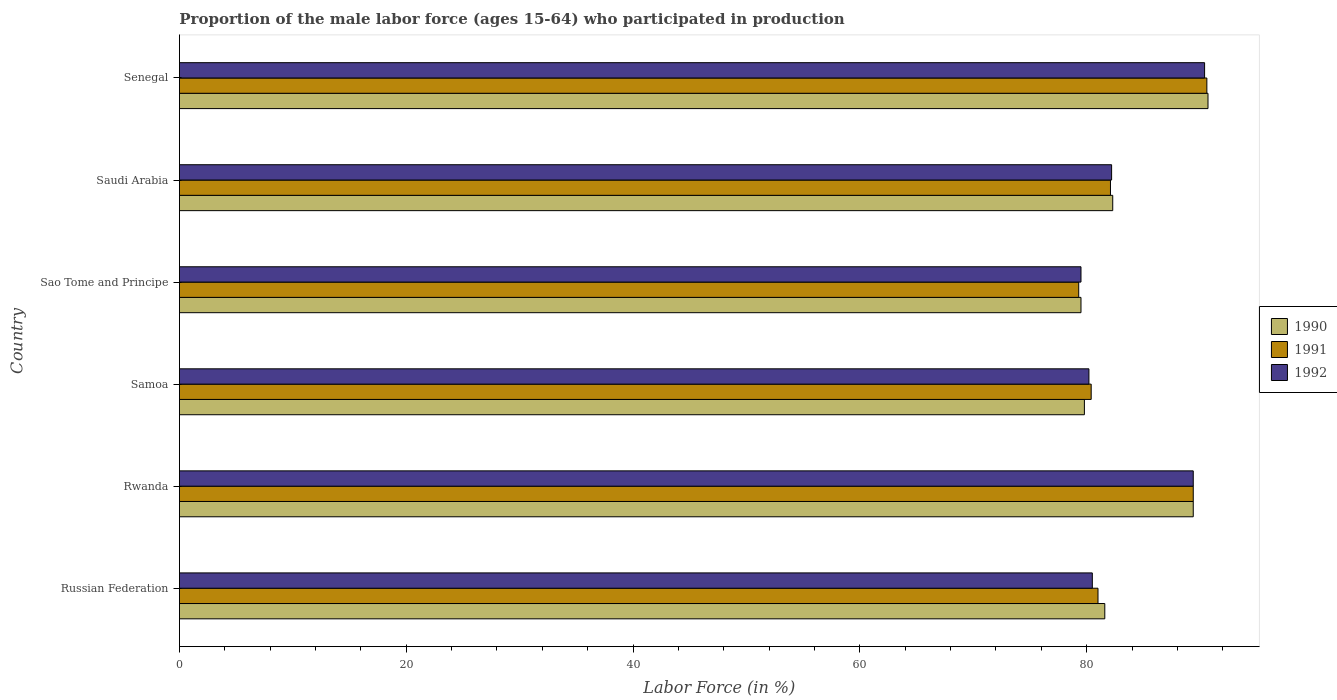How many groups of bars are there?
Offer a very short reply. 6. Are the number of bars on each tick of the Y-axis equal?
Provide a succinct answer. Yes. How many bars are there on the 6th tick from the top?
Your response must be concise. 3. What is the label of the 5th group of bars from the top?
Keep it short and to the point. Rwanda. What is the proportion of the male labor force who participated in production in 1990 in Saudi Arabia?
Provide a succinct answer. 82.3. Across all countries, what is the maximum proportion of the male labor force who participated in production in 1990?
Keep it short and to the point. 90.7. Across all countries, what is the minimum proportion of the male labor force who participated in production in 1992?
Give a very brief answer. 79.5. In which country was the proportion of the male labor force who participated in production in 1990 maximum?
Give a very brief answer. Senegal. In which country was the proportion of the male labor force who participated in production in 1991 minimum?
Offer a terse response. Sao Tome and Principe. What is the total proportion of the male labor force who participated in production in 1991 in the graph?
Ensure brevity in your answer.  502.8. What is the difference between the proportion of the male labor force who participated in production in 1992 in Samoa and that in Saudi Arabia?
Make the answer very short. -2. What is the difference between the proportion of the male labor force who participated in production in 1992 in Rwanda and the proportion of the male labor force who participated in production in 1990 in Sao Tome and Principe?
Give a very brief answer. 9.9. What is the average proportion of the male labor force who participated in production in 1992 per country?
Offer a very short reply. 83.7. What is the difference between the proportion of the male labor force who participated in production in 1992 and proportion of the male labor force who participated in production in 1991 in Saudi Arabia?
Provide a succinct answer. 0.1. What is the ratio of the proportion of the male labor force who participated in production in 1992 in Russian Federation to that in Sao Tome and Principe?
Make the answer very short. 1.01. Is the proportion of the male labor force who participated in production in 1990 in Russian Federation less than that in Senegal?
Your answer should be very brief. Yes. What is the difference between the highest and the lowest proportion of the male labor force who participated in production in 1991?
Provide a succinct answer. 11.3. In how many countries, is the proportion of the male labor force who participated in production in 1991 greater than the average proportion of the male labor force who participated in production in 1991 taken over all countries?
Your answer should be compact. 2. What does the 1st bar from the top in Saudi Arabia represents?
Your answer should be compact. 1992. Is it the case that in every country, the sum of the proportion of the male labor force who participated in production in 1991 and proportion of the male labor force who participated in production in 1992 is greater than the proportion of the male labor force who participated in production in 1990?
Your answer should be compact. Yes. How many countries are there in the graph?
Your response must be concise. 6. What is the difference between two consecutive major ticks on the X-axis?
Your answer should be very brief. 20. Does the graph contain grids?
Make the answer very short. No. Where does the legend appear in the graph?
Give a very brief answer. Center right. What is the title of the graph?
Keep it short and to the point. Proportion of the male labor force (ages 15-64) who participated in production. What is the label or title of the Y-axis?
Give a very brief answer. Country. What is the Labor Force (in %) of 1990 in Russian Federation?
Offer a very short reply. 81.6. What is the Labor Force (in %) in 1992 in Russian Federation?
Offer a very short reply. 80.5. What is the Labor Force (in %) of 1990 in Rwanda?
Your response must be concise. 89.4. What is the Labor Force (in %) of 1991 in Rwanda?
Provide a short and direct response. 89.4. What is the Labor Force (in %) in 1992 in Rwanda?
Your response must be concise. 89.4. What is the Labor Force (in %) in 1990 in Samoa?
Give a very brief answer. 79.8. What is the Labor Force (in %) in 1991 in Samoa?
Your response must be concise. 80.4. What is the Labor Force (in %) of 1992 in Samoa?
Ensure brevity in your answer.  80.2. What is the Labor Force (in %) in 1990 in Sao Tome and Principe?
Provide a short and direct response. 79.5. What is the Labor Force (in %) in 1991 in Sao Tome and Principe?
Keep it short and to the point. 79.3. What is the Labor Force (in %) in 1992 in Sao Tome and Principe?
Your answer should be very brief. 79.5. What is the Labor Force (in %) in 1990 in Saudi Arabia?
Give a very brief answer. 82.3. What is the Labor Force (in %) of 1991 in Saudi Arabia?
Your response must be concise. 82.1. What is the Labor Force (in %) in 1992 in Saudi Arabia?
Provide a succinct answer. 82.2. What is the Labor Force (in %) in 1990 in Senegal?
Ensure brevity in your answer.  90.7. What is the Labor Force (in %) of 1991 in Senegal?
Provide a succinct answer. 90.6. What is the Labor Force (in %) of 1992 in Senegal?
Provide a short and direct response. 90.4. Across all countries, what is the maximum Labor Force (in %) in 1990?
Give a very brief answer. 90.7. Across all countries, what is the maximum Labor Force (in %) of 1991?
Keep it short and to the point. 90.6. Across all countries, what is the maximum Labor Force (in %) of 1992?
Make the answer very short. 90.4. Across all countries, what is the minimum Labor Force (in %) of 1990?
Provide a succinct answer. 79.5. Across all countries, what is the minimum Labor Force (in %) of 1991?
Your answer should be compact. 79.3. Across all countries, what is the minimum Labor Force (in %) in 1992?
Provide a short and direct response. 79.5. What is the total Labor Force (in %) in 1990 in the graph?
Provide a succinct answer. 503.3. What is the total Labor Force (in %) in 1991 in the graph?
Give a very brief answer. 502.8. What is the total Labor Force (in %) in 1992 in the graph?
Make the answer very short. 502.2. What is the difference between the Labor Force (in %) in 1992 in Russian Federation and that in Samoa?
Give a very brief answer. 0.3. What is the difference between the Labor Force (in %) of 1990 in Russian Federation and that in Sao Tome and Principe?
Offer a very short reply. 2.1. What is the difference between the Labor Force (in %) in 1991 in Russian Federation and that in Sao Tome and Principe?
Your answer should be very brief. 1.7. What is the difference between the Labor Force (in %) of 1992 in Russian Federation and that in Saudi Arabia?
Provide a succinct answer. -1.7. What is the difference between the Labor Force (in %) in 1990 in Rwanda and that in Samoa?
Ensure brevity in your answer.  9.6. What is the difference between the Labor Force (in %) of 1991 in Rwanda and that in Samoa?
Provide a short and direct response. 9. What is the difference between the Labor Force (in %) of 1992 in Rwanda and that in Samoa?
Provide a succinct answer. 9.2. What is the difference between the Labor Force (in %) of 1990 in Rwanda and that in Sao Tome and Principe?
Make the answer very short. 9.9. What is the difference between the Labor Force (in %) of 1992 in Rwanda and that in Sao Tome and Principe?
Keep it short and to the point. 9.9. What is the difference between the Labor Force (in %) in 1990 in Rwanda and that in Saudi Arabia?
Ensure brevity in your answer.  7.1. What is the difference between the Labor Force (in %) of 1992 in Rwanda and that in Saudi Arabia?
Keep it short and to the point. 7.2. What is the difference between the Labor Force (in %) in 1990 in Rwanda and that in Senegal?
Keep it short and to the point. -1.3. What is the difference between the Labor Force (in %) of 1992 in Rwanda and that in Senegal?
Ensure brevity in your answer.  -1. What is the difference between the Labor Force (in %) of 1990 in Samoa and that in Saudi Arabia?
Offer a very short reply. -2.5. What is the difference between the Labor Force (in %) of 1990 in Samoa and that in Senegal?
Give a very brief answer. -10.9. What is the difference between the Labor Force (in %) in 1991 in Samoa and that in Senegal?
Your response must be concise. -10.2. What is the difference between the Labor Force (in %) in 1990 in Sao Tome and Principe and that in Saudi Arabia?
Give a very brief answer. -2.8. What is the difference between the Labor Force (in %) in 1992 in Sao Tome and Principe and that in Saudi Arabia?
Your answer should be compact. -2.7. What is the difference between the Labor Force (in %) in 1992 in Sao Tome and Principe and that in Senegal?
Give a very brief answer. -10.9. What is the difference between the Labor Force (in %) in 1990 in Saudi Arabia and that in Senegal?
Your answer should be very brief. -8.4. What is the difference between the Labor Force (in %) of 1991 in Saudi Arabia and that in Senegal?
Ensure brevity in your answer.  -8.5. What is the difference between the Labor Force (in %) of 1992 in Saudi Arabia and that in Senegal?
Provide a short and direct response. -8.2. What is the difference between the Labor Force (in %) of 1990 in Russian Federation and the Labor Force (in %) of 1991 in Rwanda?
Your answer should be very brief. -7.8. What is the difference between the Labor Force (in %) in 1990 in Russian Federation and the Labor Force (in %) in 1991 in Samoa?
Ensure brevity in your answer.  1.2. What is the difference between the Labor Force (in %) of 1990 in Russian Federation and the Labor Force (in %) of 1992 in Samoa?
Offer a terse response. 1.4. What is the difference between the Labor Force (in %) in 1991 in Russian Federation and the Labor Force (in %) in 1992 in Samoa?
Provide a short and direct response. 0.8. What is the difference between the Labor Force (in %) of 1990 in Russian Federation and the Labor Force (in %) of 1992 in Sao Tome and Principe?
Provide a succinct answer. 2.1. What is the difference between the Labor Force (in %) in 1991 in Russian Federation and the Labor Force (in %) in 1992 in Sao Tome and Principe?
Your response must be concise. 1.5. What is the difference between the Labor Force (in %) in 1990 in Russian Federation and the Labor Force (in %) in 1992 in Saudi Arabia?
Keep it short and to the point. -0.6. What is the difference between the Labor Force (in %) in 1991 in Russian Federation and the Labor Force (in %) in 1992 in Saudi Arabia?
Give a very brief answer. -1.2. What is the difference between the Labor Force (in %) of 1990 in Russian Federation and the Labor Force (in %) of 1991 in Senegal?
Offer a terse response. -9. What is the difference between the Labor Force (in %) in 1990 in Russian Federation and the Labor Force (in %) in 1992 in Senegal?
Provide a succinct answer. -8.8. What is the difference between the Labor Force (in %) of 1991 in Russian Federation and the Labor Force (in %) of 1992 in Senegal?
Give a very brief answer. -9.4. What is the difference between the Labor Force (in %) of 1990 in Rwanda and the Labor Force (in %) of 1991 in Samoa?
Your answer should be very brief. 9. What is the difference between the Labor Force (in %) in 1991 in Rwanda and the Labor Force (in %) in 1992 in Samoa?
Provide a succinct answer. 9.2. What is the difference between the Labor Force (in %) of 1990 in Rwanda and the Labor Force (in %) of 1991 in Sao Tome and Principe?
Provide a succinct answer. 10.1. What is the difference between the Labor Force (in %) in 1990 in Rwanda and the Labor Force (in %) in 1992 in Sao Tome and Principe?
Your answer should be compact. 9.9. What is the difference between the Labor Force (in %) in 1991 in Rwanda and the Labor Force (in %) in 1992 in Sao Tome and Principe?
Ensure brevity in your answer.  9.9. What is the difference between the Labor Force (in %) in 1990 in Rwanda and the Labor Force (in %) in 1991 in Saudi Arabia?
Your answer should be very brief. 7.3. What is the difference between the Labor Force (in %) in 1990 in Rwanda and the Labor Force (in %) in 1992 in Saudi Arabia?
Give a very brief answer. 7.2. What is the difference between the Labor Force (in %) of 1990 in Rwanda and the Labor Force (in %) of 1992 in Senegal?
Your answer should be very brief. -1. What is the difference between the Labor Force (in %) of 1991 in Rwanda and the Labor Force (in %) of 1992 in Senegal?
Offer a very short reply. -1. What is the difference between the Labor Force (in %) in 1990 in Samoa and the Labor Force (in %) in 1991 in Sao Tome and Principe?
Ensure brevity in your answer.  0.5. What is the difference between the Labor Force (in %) of 1990 in Samoa and the Labor Force (in %) of 1992 in Sao Tome and Principe?
Offer a very short reply. 0.3. What is the difference between the Labor Force (in %) of 1991 in Samoa and the Labor Force (in %) of 1992 in Sao Tome and Principe?
Your answer should be compact. 0.9. What is the difference between the Labor Force (in %) of 1990 in Samoa and the Labor Force (in %) of 1991 in Saudi Arabia?
Your response must be concise. -2.3. What is the difference between the Labor Force (in %) in 1991 in Samoa and the Labor Force (in %) in 1992 in Saudi Arabia?
Offer a very short reply. -1.8. What is the difference between the Labor Force (in %) of 1990 in Samoa and the Labor Force (in %) of 1991 in Senegal?
Your answer should be compact. -10.8. What is the difference between the Labor Force (in %) in 1990 in Samoa and the Labor Force (in %) in 1992 in Senegal?
Ensure brevity in your answer.  -10.6. What is the difference between the Labor Force (in %) of 1990 in Sao Tome and Principe and the Labor Force (in %) of 1992 in Saudi Arabia?
Your response must be concise. -2.7. What is the difference between the Labor Force (in %) of 1991 in Sao Tome and Principe and the Labor Force (in %) of 1992 in Saudi Arabia?
Provide a short and direct response. -2.9. What is the difference between the Labor Force (in %) of 1990 in Sao Tome and Principe and the Labor Force (in %) of 1992 in Senegal?
Give a very brief answer. -10.9. What is the difference between the Labor Force (in %) in 1991 in Sao Tome and Principe and the Labor Force (in %) in 1992 in Senegal?
Offer a terse response. -11.1. What is the average Labor Force (in %) in 1990 per country?
Offer a very short reply. 83.88. What is the average Labor Force (in %) in 1991 per country?
Give a very brief answer. 83.8. What is the average Labor Force (in %) of 1992 per country?
Offer a terse response. 83.7. What is the difference between the Labor Force (in %) in 1990 and Labor Force (in %) in 1992 in Russian Federation?
Your answer should be compact. 1.1. What is the difference between the Labor Force (in %) in 1991 and Labor Force (in %) in 1992 in Russian Federation?
Your answer should be very brief. 0.5. What is the difference between the Labor Force (in %) of 1990 and Labor Force (in %) of 1991 in Rwanda?
Give a very brief answer. 0. What is the difference between the Labor Force (in %) in 1990 and Labor Force (in %) in 1992 in Rwanda?
Offer a very short reply. 0. What is the difference between the Labor Force (in %) in 1991 and Labor Force (in %) in 1992 in Rwanda?
Offer a terse response. 0. What is the difference between the Labor Force (in %) of 1990 and Labor Force (in %) of 1991 in Samoa?
Give a very brief answer. -0.6. What is the difference between the Labor Force (in %) in 1990 and Labor Force (in %) in 1992 in Samoa?
Your response must be concise. -0.4. What is the difference between the Labor Force (in %) of 1991 and Labor Force (in %) of 1992 in Samoa?
Your response must be concise. 0.2. What is the difference between the Labor Force (in %) in 1990 and Labor Force (in %) in 1992 in Sao Tome and Principe?
Your answer should be very brief. 0. What is the difference between the Labor Force (in %) in 1990 and Labor Force (in %) in 1992 in Saudi Arabia?
Your answer should be very brief. 0.1. What is the difference between the Labor Force (in %) in 1990 and Labor Force (in %) in 1991 in Senegal?
Make the answer very short. 0.1. What is the difference between the Labor Force (in %) of 1990 and Labor Force (in %) of 1992 in Senegal?
Your answer should be compact. 0.3. What is the ratio of the Labor Force (in %) in 1990 in Russian Federation to that in Rwanda?
Ensure brevity in your answer.  0.91. What is the ratio of the Labor Force (in %) of 1991 in Russian Federation to that in Rwanda?
Ensure brevity in your answer.  0.91. What is the ratio of the Labor Force (in %) in 1992 in Russian Federation to that in Rwanda?
Your answer should be compact. 0.9. What is the ratio of the Labor Force (in %) in 1990 in Russian Federation to that in Samoa?
Make the answer very short. 1.02. What is the ratio of the Labor Force (in %) of 1991 in Russian Federation to that in Samoa?
Offer a terse response. 1.01. What is the ratio of the Labor Force (in %) in 1992 in Russian Federation to that in Samoa?
Make the answer very short. 1. What is the ratio of the Labor Force (in %) of 1990 in Russian Federation to that in Sao Tome and Principe?
Make the answer very short. 1.03. What is the ratio of the Labor Force (in %) of 1991 in Russian Federation to that in Sao Tome and Principe?
Your answer should be compact. 1.02. What is the ratio of the Labor Force (in %) of 1992 in Russian Federation to that in Sao Tome and Principe?
Keep it short and to the point. 1.01. What is the ratio of the Labor Force (in %) of 1990 in Russian Federation to that in Saudi Arabia?
Offer a very short reply. 0.99. What is the ratio of the Labor Force (in %) of 1991 in Russian Federation to that in Saudi Arabia?
Offer a terse response. 0.99. What is the ratio of the Labor Force (in %) in 1992 in Russian Federation to that in Saudi Arabia?
Your answer should be compact. 0.98. What is the ratio of the Labor Force (in %) in 1990 in Russian Federation to that in Senegal?
Offer a terse response. 0.9. What is the ratio of the Labor Force (in %) in 1991 in Russian Federation to that in Senegal?
Your answer should be compact. 0.89. What is the ratio of the Labor Force (in %) of 1992 in Russian Federation to that in Senegal?
Provide a short and direct response. 0.89. What is the ratio of the Labor Force (in %) of 1990 in Rwanda to that in Samoa?
Give a very brief answer. 1.12. What is the ratio of the Labor Force (in %) in 1991 in Rwanda to that in Samoa?
Offer a very short reply. 1.11. What is the ratio of the Labor Force (in %) of 1992 in Rwanda to that in Samoa?
Give a very brief answer. 1.11. What is the ratio of the Labor Force (in %) in 1990 in Rwanda to that in Sao Tome and Principe?
Provide a short and direct response. 1.12. What is the ratio of the Labor Force (in %) of 1991 in Rwanda to that in Sao Tome and Principe?
Your answer should be compact. 1.13. What is the ratio of the Labor Force (in %) in 1992 in Rwanda to that in Sao Tome and Principe?
Ensure brevity in your answer.  1.12. What is the ratio of the Labor Force (in %) of 1990 in Rwanda to that in Saudi Arabia?
Offer a very short reply. 1.09. What is the ratio of the Labor Force (in %) in 1991 in Rwanda to that in Saudi Arabia?
Offer a very short reply. 1.09. What is the ratio of the Labor Force (in %) in 1992 in Rwanda to that in Saudi Arabia?
Your response must be concise. 1.09. What is the ratio of the Labor Force (in %) of 1990 in Rwanda to that in Senegal?
Provide a succinct answer. 0.99. What is the ratio of the Labor Force (in %) of 1991 in Rwanda to that in Senegal?
Make the answer very short. 0.99. What is the ratio of the Labor Force (in %) in 1992 in Rwanda to that in Senegal?
Provide a succinct answer. 0.99. What is the ratio of the Labor Force (in %) of 1991 in Samoa to that in Sao Tome and Principe?
Keep it short and to the point. 1.01. What is the ratio of the Labor Force (in %) of 1992 in Samoa to that in Sao Tome and Principe?
Ensure brevity in your answer.  1.01. What is the ratio of the Labor Force (in %) of 1990 in Samoa to that in Saudi Arabia?
Offer a very short reply. 0.97. What is the ratio of the Labor Force (in %) of 1991 in Samoa to that in Saudi Arabia?
Keep it short and to the point. 0.98. What is the ratio of the Labor Force (in %) of 1992 in Samoa to that in Saudi Arabia?
Provide a short and direct response. 0.98. What is the ratio of the Labor Force (in %) of 1990 in Samoa to that in Senegal?
Give a very brief answer. 0.88. What is the ratio of the Labor Force (in %) of 1991 in Samoa to that in Senegal?
Make the answer very short. 0.89. What is the ratio of the Labor Force (in %) of 1992 in Samoa to that in Senegal?
Give a very brief answer. 0.89. What is the ratio of the Labor Force (in %) of 1990 in Sao Tome and Principe to that in Saudi Arabia?
Ensure brevity in your answer.  0.97. What is the ratio of the Labor Force (in %) of 1991 in Sao Tome and Principe to that in Saudi Arabia?
Offer a very short reply. 0.97. What is the ratio of the Labor Force (in %) of 1992 in Sao Tome and Principe to that in Saudi Arabia?
Ensure brevity in your answer.  0.97. What is the ratio of the Labor Force (in %) in 1990 in Sao Tome and Principe to that in Senegal?
Your answer should be compact. 0.88. What is the ratio of the Labor Force (in %) in 1991 in Sao Tome and Principe to that in Senegal?
Your answer should be very brief. 0.88. What is the ratio of the Labor Force (in %) of 1992 in Sao Tome and Principe to that in Senegal?
Make the answer very short. 0.88. What is the ratio of the Labor Force (in %) of 1990 in Saudi Arabia to that in Senegal?
Keep it short and to the point. 0.91. What is the ratio of the Labor Force (in %) of 1991 in Saudi Arabia to that in Senegal?
Provide a short and direct response. 0.91. What is the ratio of the Labor Force (in %) in 1992 in Saudi Arabia to that in Senegal?
Make the answer very short. 0.91. What is the difference between the highest and the second highest Labor Force (in %) in 1990?
Give a very brief answer. 1.3. What is the difference between the highest and the second highest Labor Force (in %) in 1991?
Ensure brevity in your answer.  1.2. What is the difference between the highest and the lowest Labor Force (in %) in 1990?
Your response must be concise. 11.2. What is the difference between the highest and the lowest Labor Force (in %) of 1992?
Your answer should be very brief. 10.9. 